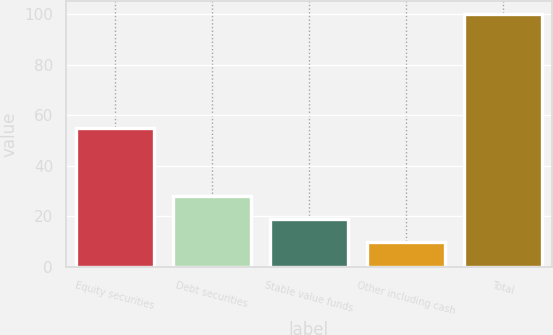Convert chart. <chart><loc_0><loc_0><loc_500><loc_500><bar_chart><fcel>Equity securities<fcel>Debt securities<fcel>Stable value funds<fcel>Other including cash<fcel>Total<nl><fcel>55<fcel>28<fcel>19<fcel>10<fcel>100<nl></chart> 